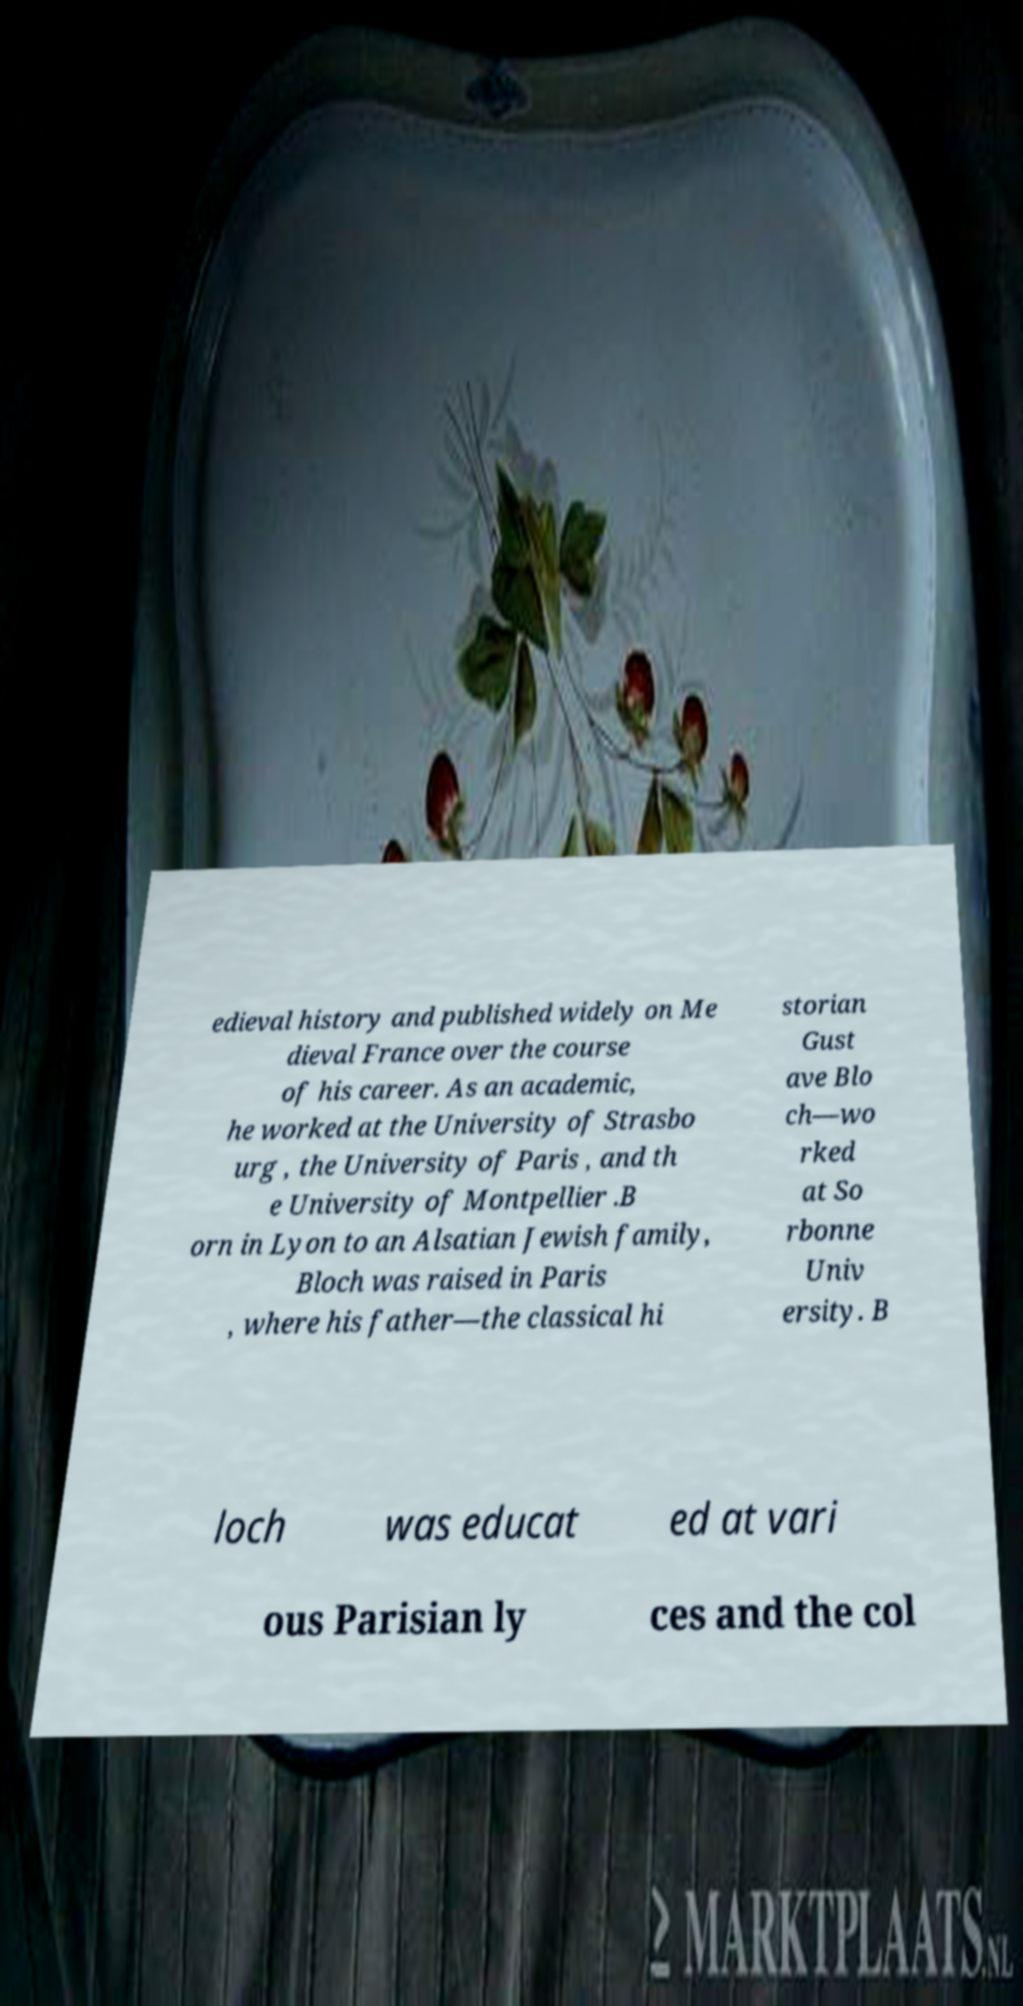Can you accurately transcribe the text from the provided image for me? edieval history and published widely on Me dieval France over the course of his career. As an academic, he worked at the University of Strasbo urg , the University of Paris , and th e University of Montpellier .B orn in Lyon to an Alsatian Jewish family, Bloch was raised in Paris , where his father—the classical hi storian Gust ave Blo ch—wo rked at So rbonne Univ ersity. B loch was educat ed at vari ous Parisian ly ces and the col 